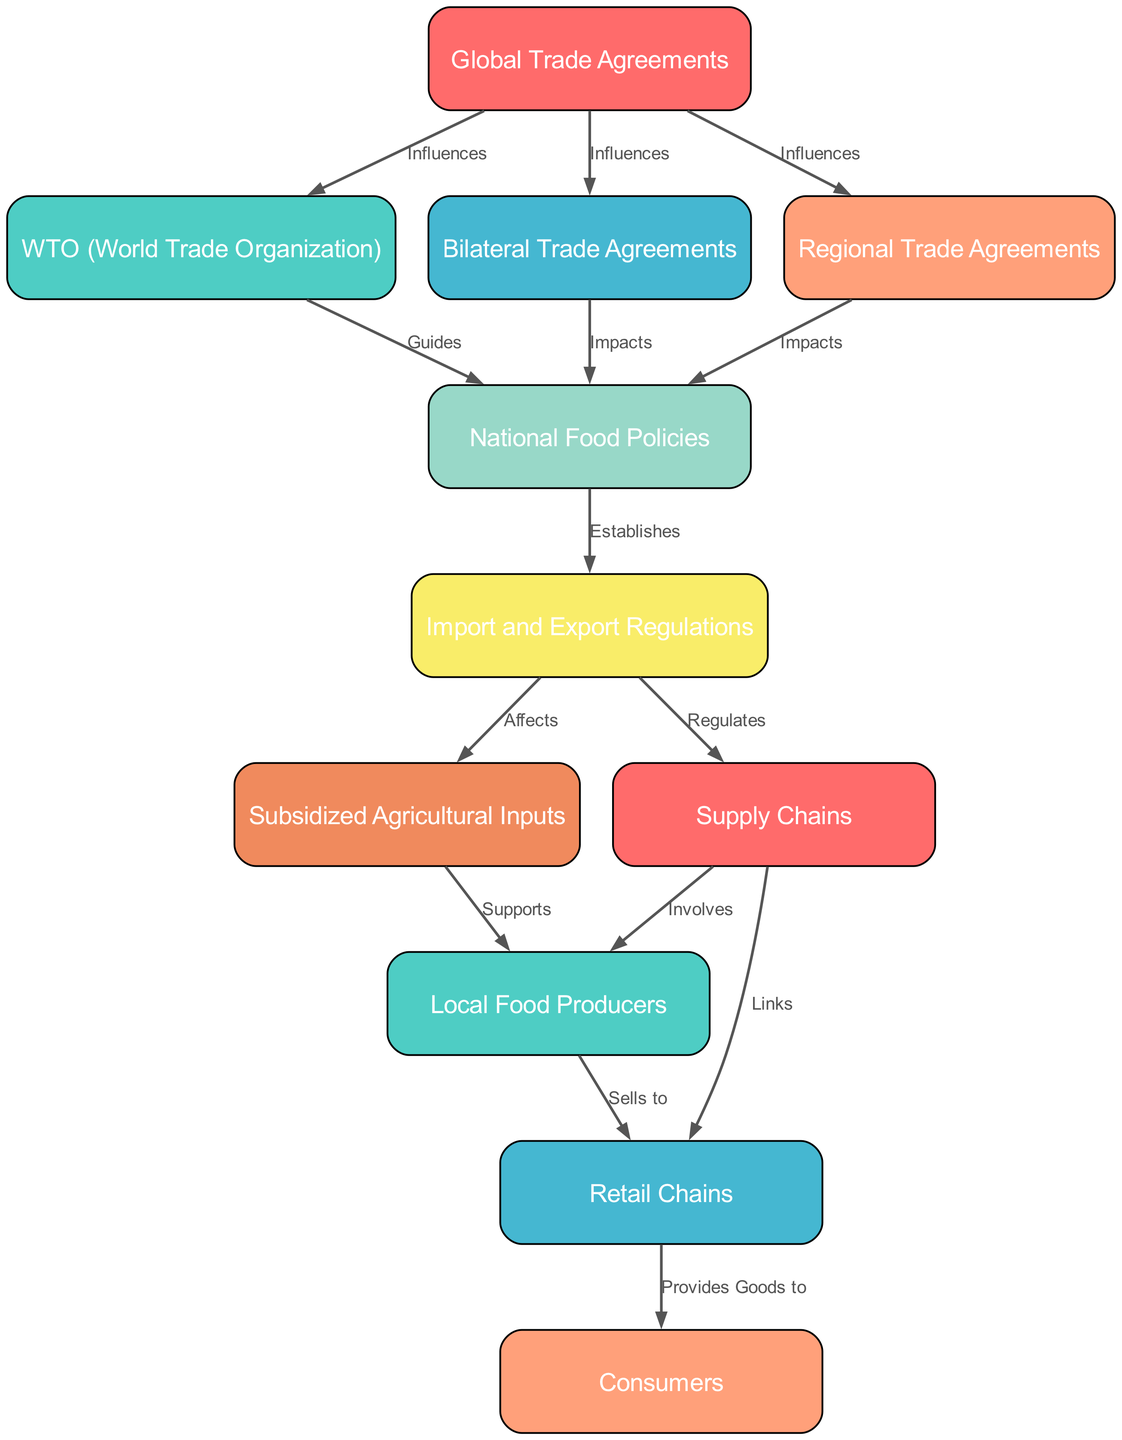What is the starting point of the food chain in the diagram? The starting point is the node labeled "Global Trade Agreements," indicated as the first node in the diagram.
Answer: Global Trade Agreements How many types of trade agreements are represented in the diagram? There are three types represented: WTO (World Trade Organization), Bilateral Trade Agreements, and Regional Trade Agreements, totaling three.
Answer: 3 Which node is most directly impacted by Bilateral Trade Agreements? The node directly impacted by Bilateral Trade Agreements is "National Food Policies," as indicated by the edge labeled "Impacts" leading from node 3 to node 5.
Answer: National Food Policies What type of relationship exists between Import and Export Regulations and Subsidized Agricultural Inputs? The relationship is labeled "Affects," which indicates that Import and Export Regulations have an effect on Subsidized Agricultural Inputs, emphasizing a regulatory influence.
Answer: Affects What do Retail Chains provide goods to? Retail Chains provide goods to "Consumers," as shown by the edge that indicates this direct relationship.
Answer: Consumers Describe the connection between Supply Chains and Local Food Producers. The connection is that Supply Chains "Involve" Local Food Producers, indicating their role within the larger supply network as essential contributors to food availability.
Answer: Involves Which node is guided by the WTO? The node that is guided by the WTO is "National Food Policies," as it is directly connected with the label "Guides" from node 2 to node 5.
Answer: National Food Policies What influences the connections in the diagram? The connections in the diagram are influenced by "Global Trade Agreements," which shape the relationships and processes among various components of the food chain.
Answer: Global Trade Agreements What is the last node that supplies goods in this food chain? The last node supplying goods in this food chain is "Consumers," as it is the endpoint of the flow connecting from both Retail Chains and Local Food Producers.
Answer: Consumers 